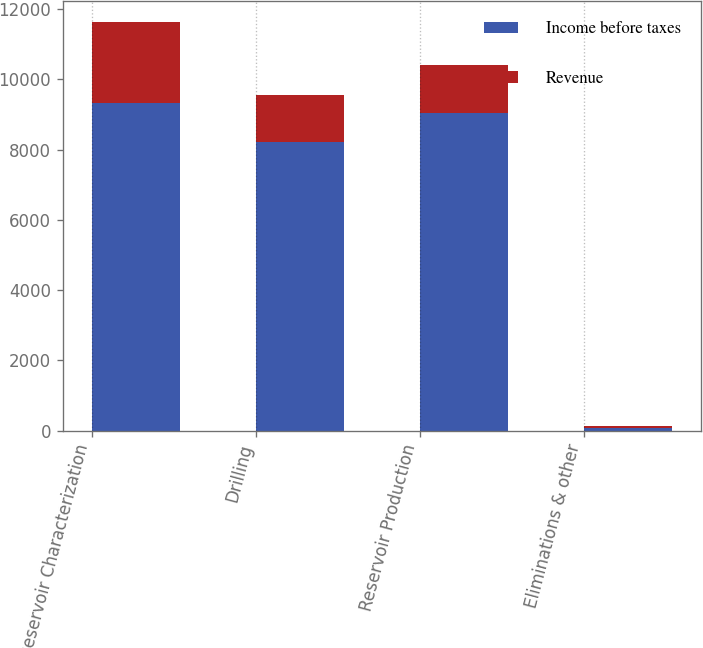Convert chart. <chart><loc_0><loc_0><loc_500><loc_500><stacked_bar_chart><ecel><fcel>Reservoir Characterization<fcel>Drilling<fcel>Reservoir Production<fcel>Eliminations & other<nl><fcel>Income before taxes<fcel>9321<fcel>8230<fcel>9053<fcel>69<nl><fcel>Revenue<fcel>2321<fcel>1334<fcel>1368<fcel>48<nl></chart> 